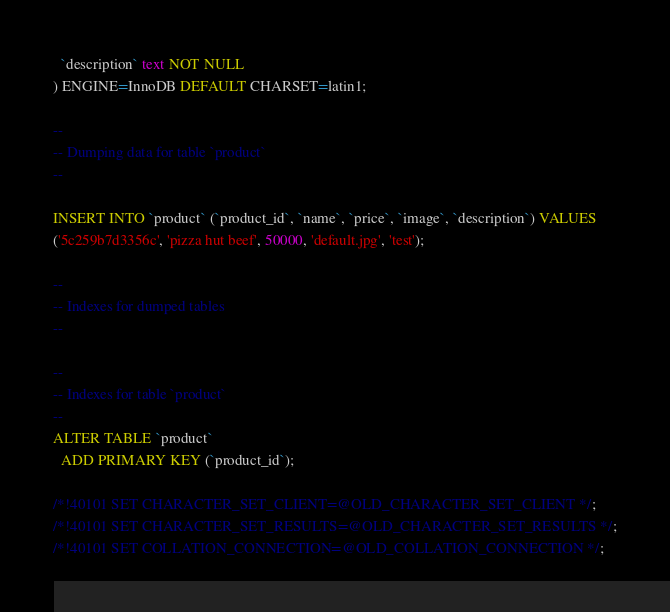Convert code to text. <code><loc_0><loc_0><loc_500><loc_500><_SQL_>  `description` text NOT NULL
) ENGINE=InnoDB DEFAULT CHARSET=latin1;

--
-- Dumping data for table `product`
--

INSERT INTO `product` (`product_id`, `name`, `price`, `image`, `description`) VALUES
('5c259b7d3356c', 'pizza hut beef', 50000, 'default.jpg', 'test');

--
-- Indexes for dumped tables
--

--
-- Indexes for table `product`
--
ALTER TABLE `product`
  ADD PRIMARY KEY (`product_id`);

/*!40101 SET CHARACTER_SET_CLIENT=@OLD_CHARACTER_SET_CLIENT */;
/*!40101 SET CHARACTER_SET_RESULTS=@OLD_CHARACTER_SET_RESULTS */;
/*!40101 SET COLLATION_CONNECTION=@OLD_COLLATION_CONNECTION */;
</code> 